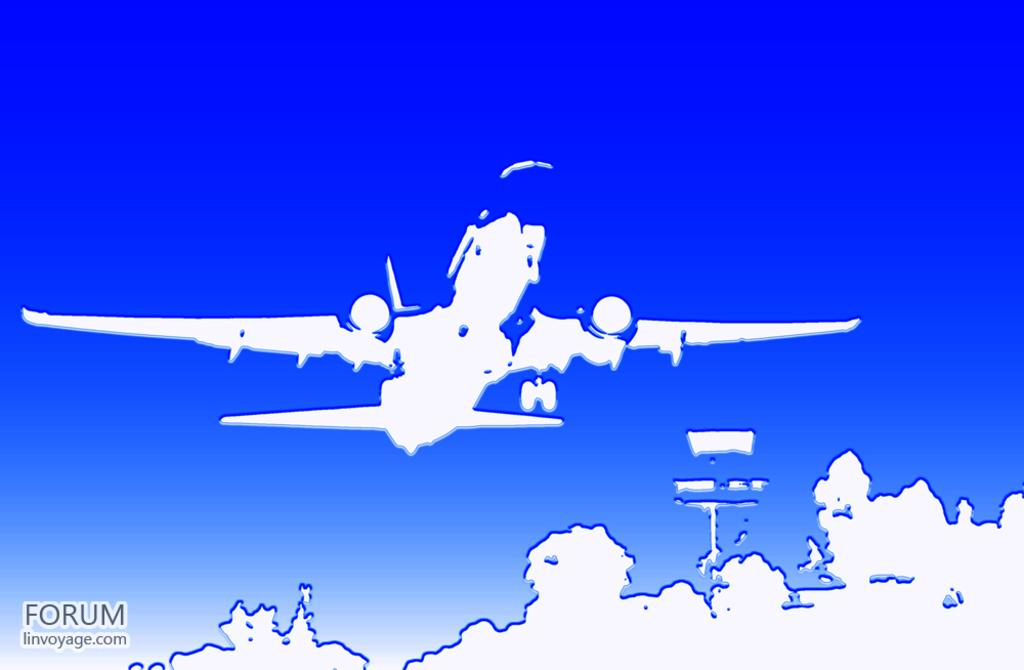What can be observed about the image's appearance? The image is edited. What is the main subject in the center of the image? There is an aeroplane in the center of the image. What type of natural elements are present at the bottom of the image? There are trees at the bottom of the image. What structure can be seen at the bottom of the image? There is a pole at the bottom of the image. How many stars can be seen flying in the image? There are no stars visible in the image, nor are any flying. 